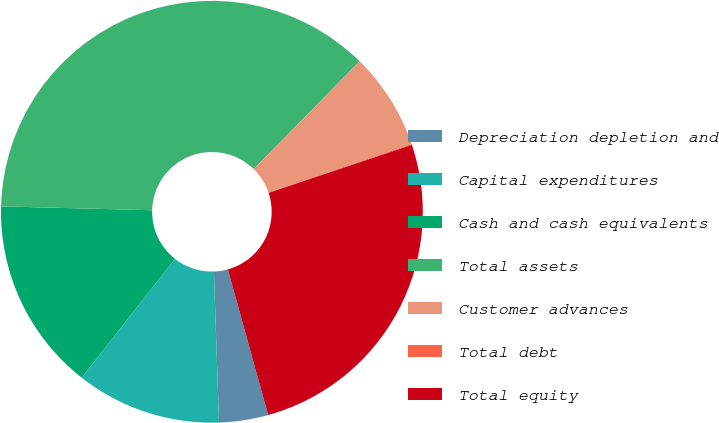Convert chart. <chart><loc_0><loc_0><loc_500><loc_500><pie_chart><fcel>Depreciation depletion and<fcel>Capital expenditures<fcel>Cash and cash equivalents<fcel>Total assets<fcel>Customer advances<fcel>Total debt<fcel>Total equity<nl><fcel>3.76%<fcel>11.13%<fcel>14.82%<fcel>36.94%<fcel>7.44%<fcel>0.07%<fcel>25.84%<nl></chart> 